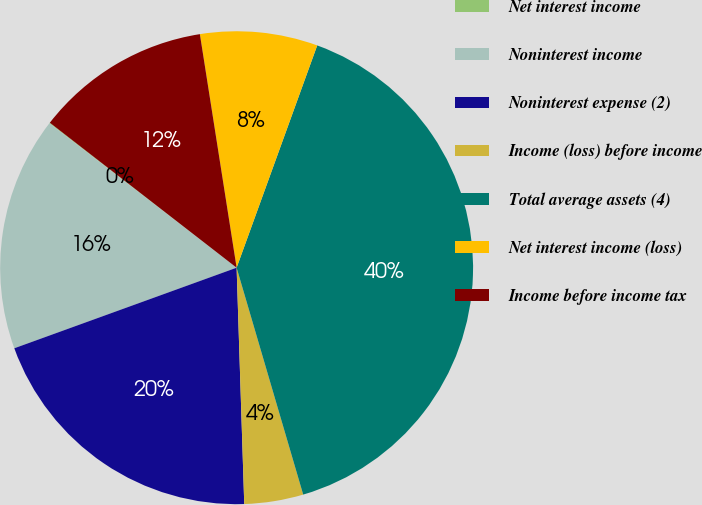Convert chart to OTSL. <chart><loc_0><loc_0><loc_500><loc_500><pie_chart><fcel>Net interest income<fcel>Noninterest income<fcel>Noninterest expense (2)<fcel>Income (loss) before income<fcel>Total average assets (4)<fcel>Net interest income (loss)<fcel>Income before income tax<nl><fcel>0.05%<fcel>15.99%<fcel>19.98%<fcel>4.03%<fcel>39.92%<fcel>8.02%<fcel>12.01%<nl></chart> 